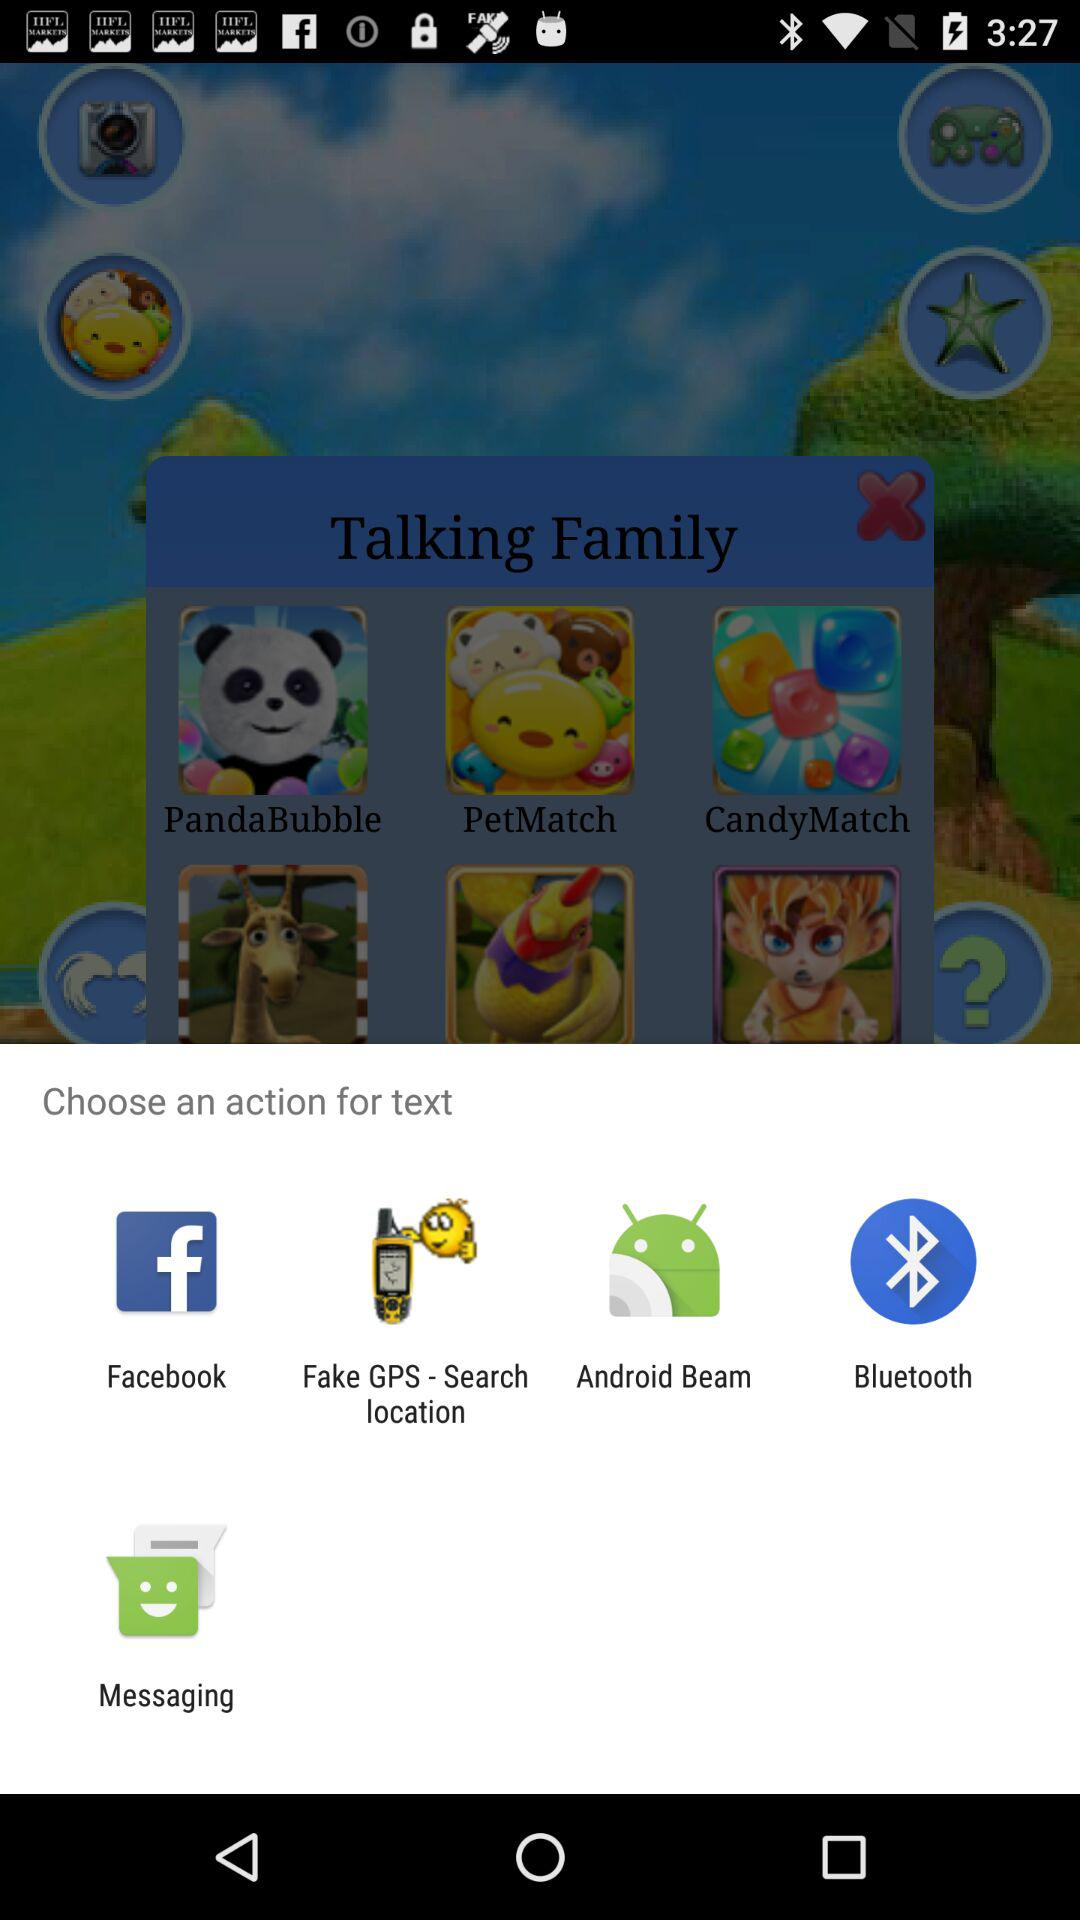How many followers are there?
When the provided information is insufficient, respond with <no answer>. <no answer> 